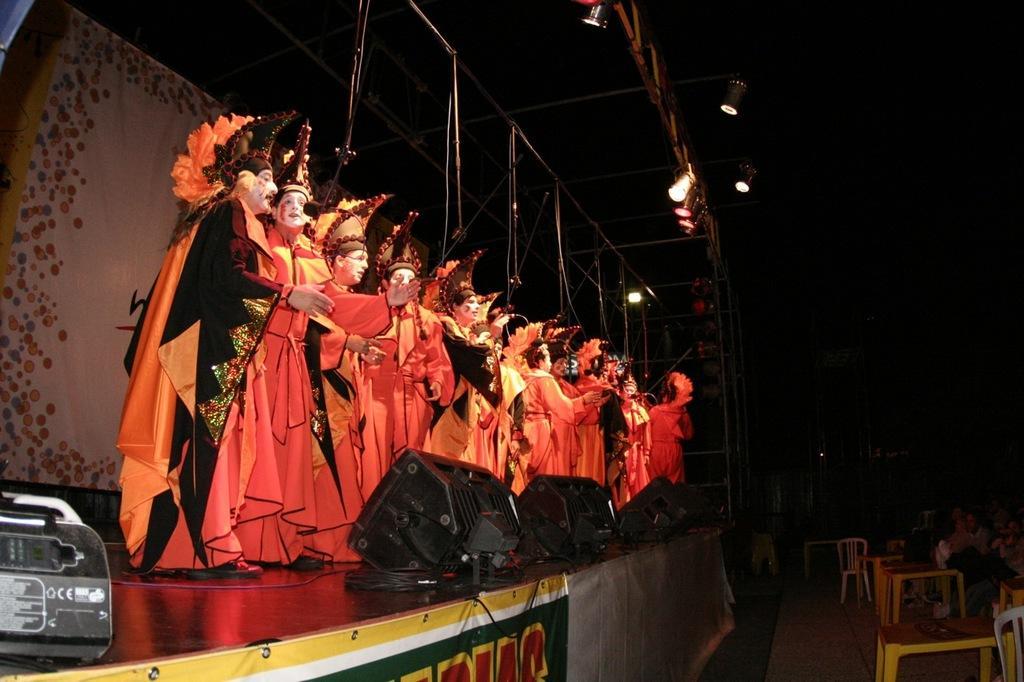Please provide a concise description of this image. At the top we can see lights. On the platform we can see all the persons performing in a fancy dress. These are devices. Near to the platform we can see chairs. 